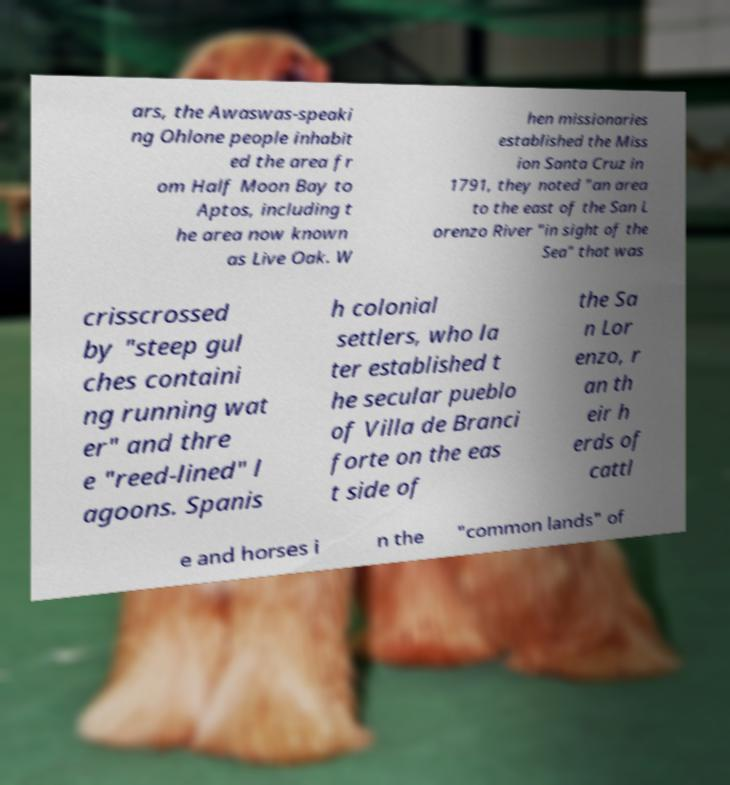Could you assist in decoding the text presented in this image and type it out clearly? ars, the Awaswas-speaki ng Ohlone people inhabit ed the area fr om Half Moon Bay to Aptos, including t he area now known as Live Oak. W hen missionaries established the Miss ion Santa Cruz in 1791, they noted "an area to the east of the San L orenzo River "in sight of the Sea" that was crisscrossed by "steep gul ches containi ng running wat er" and thre e "reed-lined" l agoons. Spanis h colonial settlers, who la ter established t he secular pueblo of Villa de Branci forte on the eas t side of the Sa n Lor enzo, r an th eir h erds of cattl e and horses i n the "common lands" of 